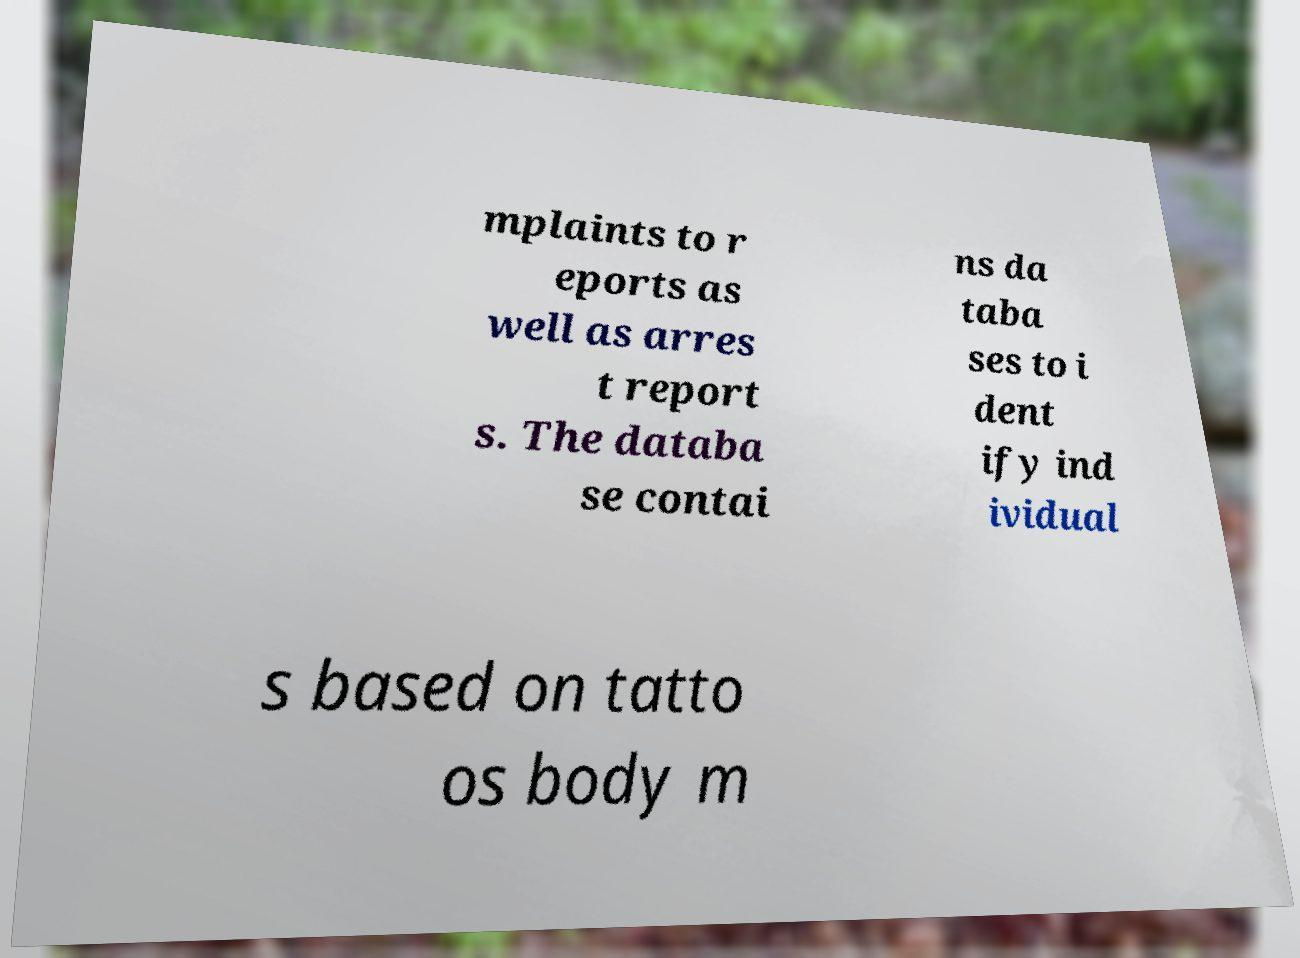There's text embedded in this image that I need extracted. Can you transcribe it verbatim? mplaints to r eports as well as arres t report s. The databa se contai ns da taba ses to i dent ify ind ividual s based on tatto os body m 